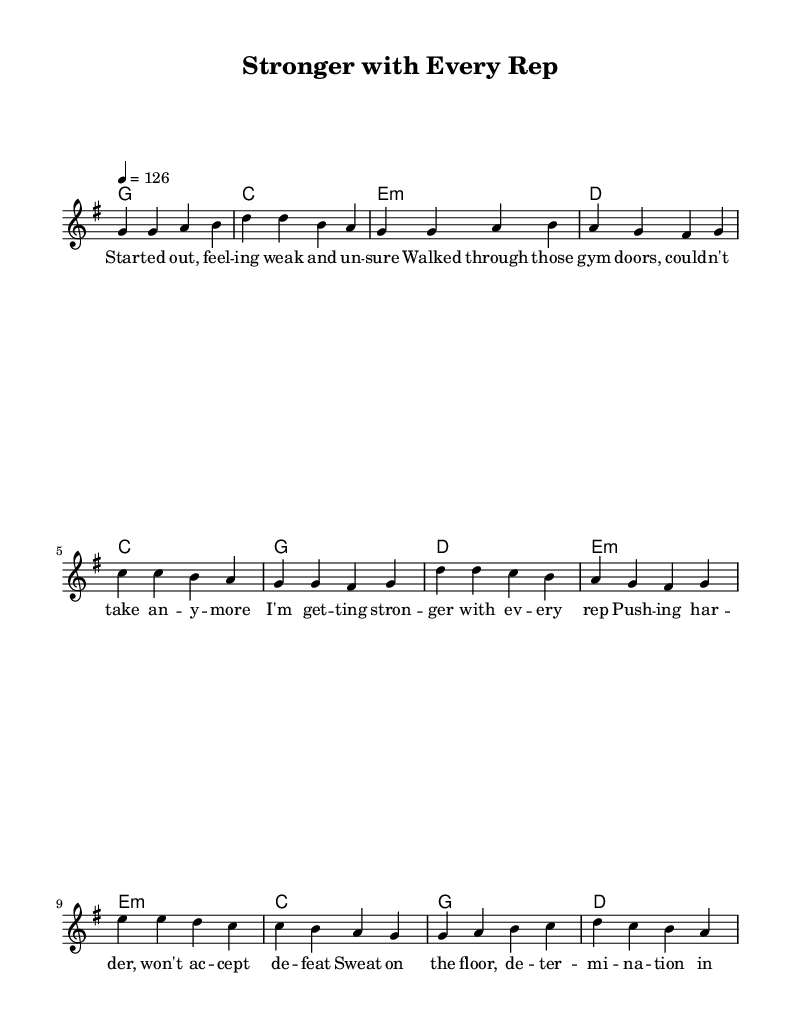What is the key signature of this music? The key signature for the music is G major, which has one sharp (F#). This can be identified from the key indication at the beginning of the score.
Answer: G major What is the time signature of this music? The time signature is 4/4, which means there are four beats per measure and the quarter note gets one beat. This is indicated at the start of the sheet music.
Answer: 4/4 What is the tempo marking of this song? The tempo marking is indicated as 126 beats per minute, which reveals the speed of the song. This is found in the tempo indication at the beginning of the score.
Answer: 126 How many sections are present in the song? There are three main sections in the song: the verse, the chorus, and the bridge. This can be determined by the titles and structure presented in the music.
Answer: Three What chords are used in the chorus? The chords used in the chorus are C, G, D, and E minor. This information can be extracted from the chord changes written above the lyrics for that section.
Answer: C, G, D, E minor What is the first lyric of the song? The first lyric of the song is "Started out, feeling weak and unsure." This can be found at the beginning of the lyrics section of the sheet music.
Answer: Started out, feeling weak and unsure What is the main theme of this song? The main theme of the song revolves around personal fitness journeys and determination. This theme can be inferred from the lyrics, which discuss overcoming challenges and building strength through workouts.
Answer: Personal fitness journeys 